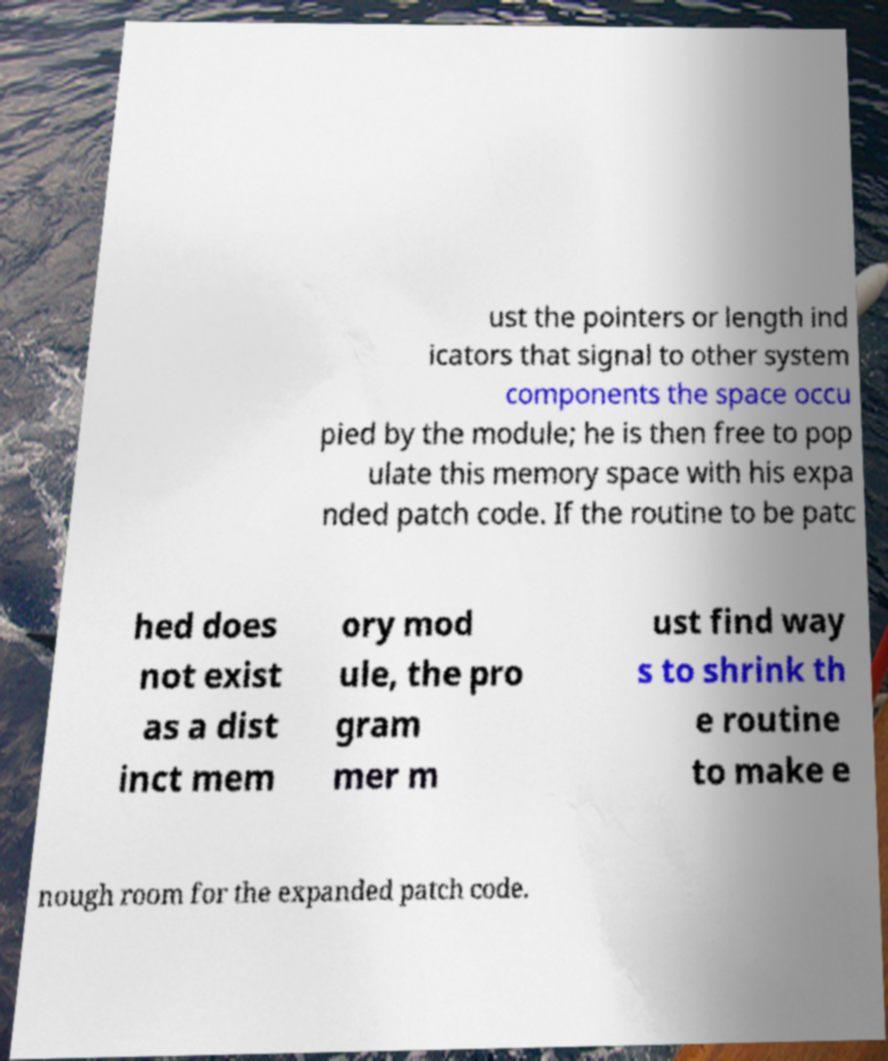Can you read and provide the text displayed in the image?This photo seems to have some interesting text. Can you extract and type it out for me? ust the pointers or length ind icators that signal to other system components the space occu pied by the module; he is then free to pop ulate this memory space with his expa nded patch code. If the routine to be patc hed does not exist as a dist inct mem ory mod ule, the pro gram mer m ust find way s to shrink th e routine to make e nough room for the expanded patch code. 